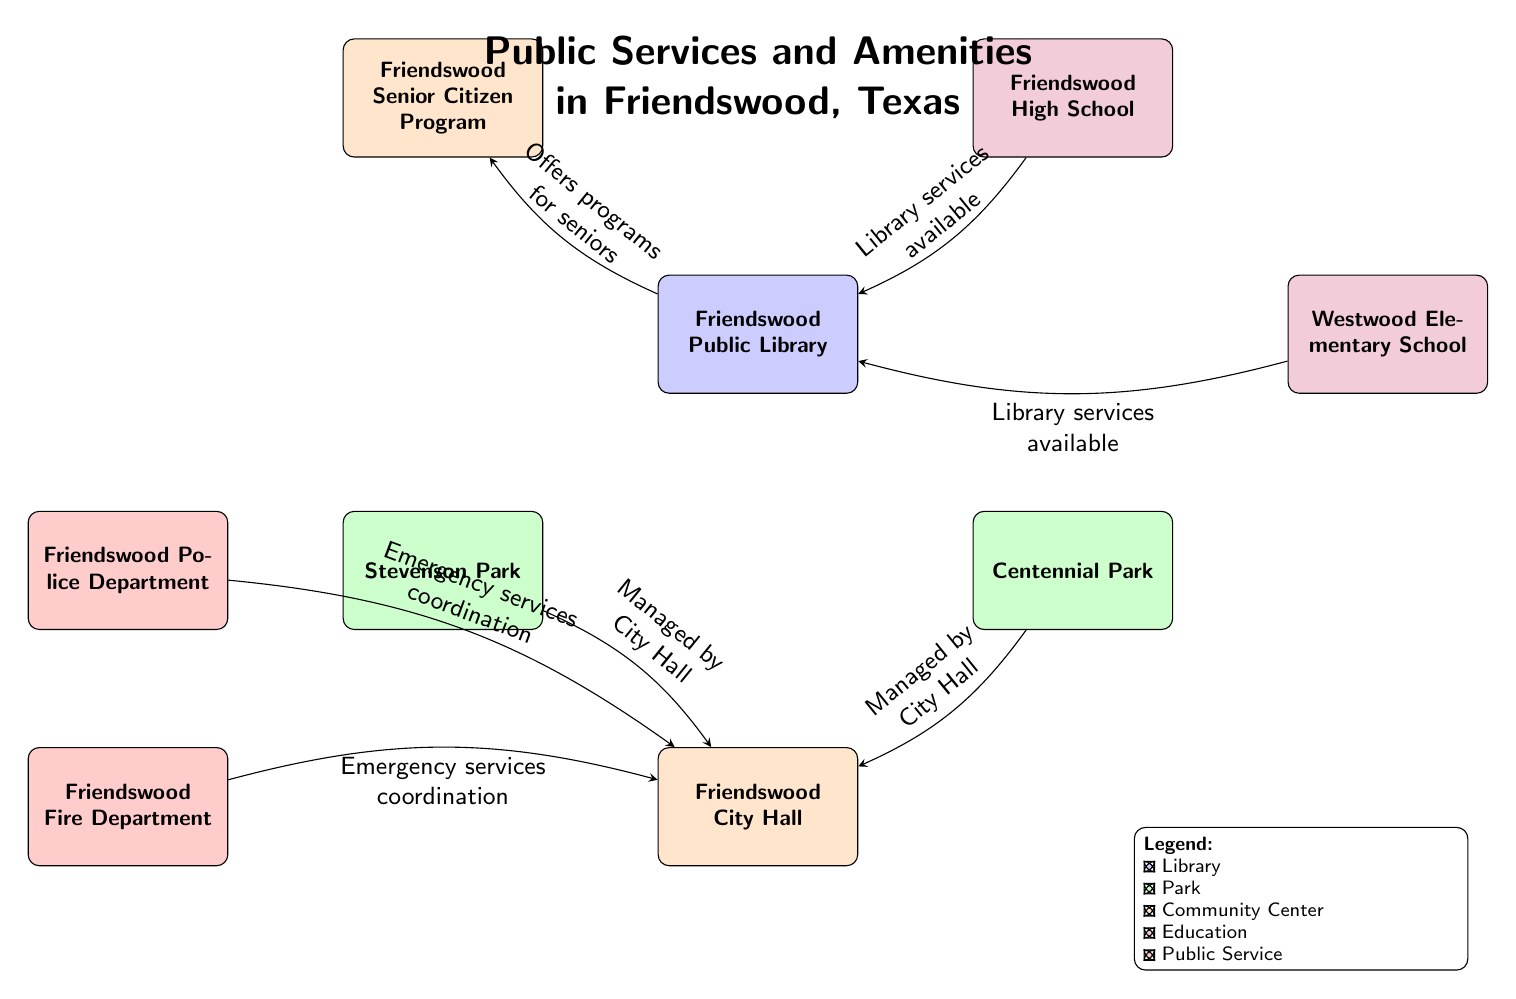What public library is included in the diagram? The diagram specifically identifies the node labeled "Friendswood Public Library" under the category of Library, which is the only public library mentioned.
Answer: Friendswood Public Library How many parks are represented in the diagram? There are two nodes classified as Parks: "Stevenson Park" and "Centennial Park." Counting both nodes gives us the total number of parks represented in the diagram.
Answer: 2 Which community center serves the Friendswood Senior Citizen Program? The diagram shows an arrow (edge) connecting the "Friendswood Public Library" to the "Friendswood Senior Citizen Program," indicating that this program is the community center associated with the library for offering services to seniors.
Answer: Friendswood Senior Citizen Program How many educational nodes are present in the diagram? The nodes labeled "Friendswood High School" and "Westwood Elementary School" represent educational institutions. Counting these nodes provides the total number of educational nodes in the diagram.
Answer: 2 What is the connection between the Friendswood Police Department and the Community Center? There is an edge that indicates "Emergency services coordination" between the "Friendswood Police Department" and the "Friendswood City Hall" (Community Center), displaying how the police department coordinates emergency services with the community center.
Answer: Emergency services coordination What color represents parks in this diagram? The color coding for parks in the diagram is represented by a green shade, as indicated by the specific style used for the Park nodes.
Answer: Green!20 Which entity offers library services at Westwood Elementary School? The arrow connecting "Westwood Elementary School" to the "Friendswood Public Library" signifies that library services are available at the elementary school through the library.
Answer: Library services available How many total public service nodes are shown in the diagram? There are two nodes labeled as Public Services: "Friendswood Police Department" and "Friendswood Fire Department." Counting these nodes will provide the total number of public service nodes.
Answer: 2 